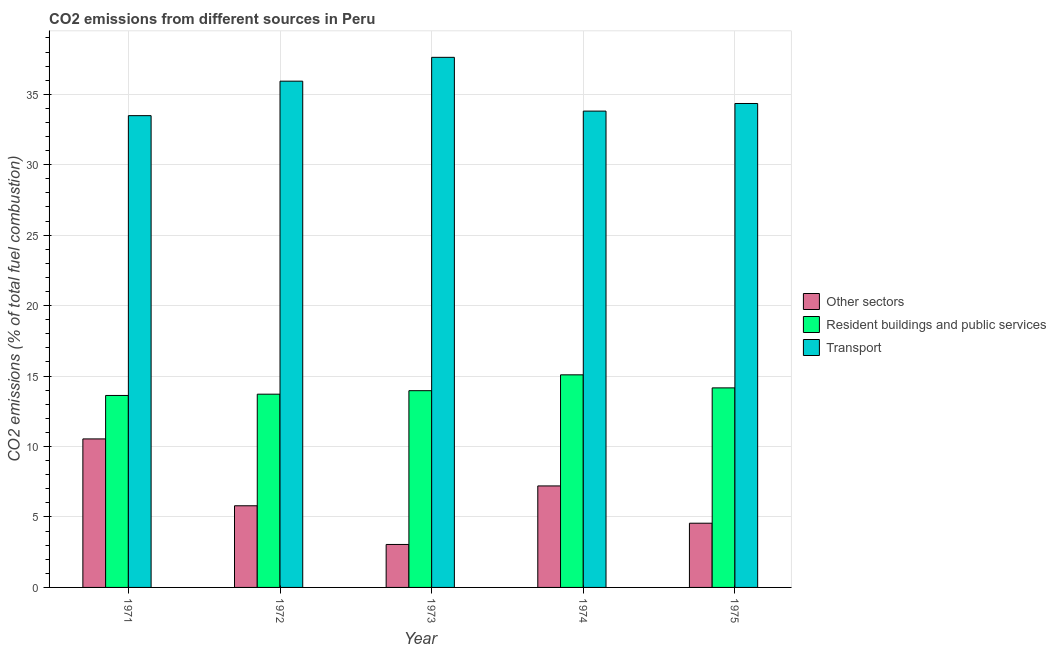How many different coloured bars are there?
Ensure brevity in your answer.  3. How many groups of bars are there?
Give a very brief answer. 5. Are the number of bars on each tick of the X-axis equal?
Your answer should be very brief. Yes. What is the label of the 3rd group of bars from the left?
Ensure brevity in your answer.  1973. What is the percentage of co2 emissions from transport in 1975?
Make the answer very short. 34.35. Across all years, what is the maximum percentage of co2 emissions from transport?
Provide a succinct answer. 37.62. Across all years, what is the minimum percentage of co2 emissions from resident buildings and public services?
Your response must be concise. 13.62. In which year was the percentage of co2 emissions from resident buildings and public services maximum?
Provide a succinct answer. 1974. In which year was the percentage of co2 emissions from resident buildings and public services minimum?
Keep it short and to the point. 1971. What is the total percentage of co2 emissions from resident buildings and public services in the graph?
Offer a very short reply. 70.55. What is the difference between the percentage of co2 emissions from other sectors in 1971 and that in 1973?
Give a very brief answer. 7.49. What is the difference between the percentage of co2 emissions from other sectors in 1972 and the percentage of co2 emissions from resident buildings and public services in 1974?
Make the answer very short. -1.41. What is the average percentage of co2 emissions from transport per year?
Keep it short and to the point. 35.04. In the year 1972, what is the difference between the percentage of co2 emissions from transport and percentage of co2 emissions from resident buildings and public services?
Your answer should be very brief. 0. In how many years, is the percentage of co2 emissions from other sectors greater than 18 %?
Give a very brief answer. 0. What is the ratio of the percentage of co2 emissions from resident buildings and public services in 1972 to that in 1974?
Provide a succinct answer. 0.91. Is the difference between the percentage of co2 emissions from resident buildings and public services in 1974 and 1975 greater than the difference between the percentage of co2 emissions from other sectors in 1974 and 1975?
Provide a short and direct response. No. What is the difference between the highest and the second highest percentage of co2 emissions from other sectors?
Your answer should be compact. 3.34. What is the difference between the highest and the lowest percentage of co2 emissions from other sectors?
Your answer should be very brief. 7.49. In how many years, is the percentage of co2 emissions from other sectors greater than the average percentage of co2 emissions from other sectors taken over all years?
Make the answer very short. 2. What does the 3rd bar from the left in 1971 represents?
Provide a succinct answer. Transport. What does the 2nd bar from the right in 1971 represents?
Offer a terse response. Resident buildings and public services. How many bars are there?
Give a very brief answer. 15. How many years are there in the graph?
Offer a terse response. 5. What is the difference between two consecutive major ticks on the Y-axis?
Your answer should be very brief. 5. Where does the legend appear in the graph?
Ensure brevity in your answer.  Center right. What is the title of the graph?
Your answer should be very brief. CO2 emissions from different sources in Peru. Does "New Zealand" appear as one of the legend labels in the graph?
Your answer should be very brief. No. What is the label or title of the Y-axis?
Offer a terse response. CO2 emissions (% of total fuel combustion). What is the CO2 emissions (% of total fuel combustion) in Other sectors in 1971?
Provide a succinct answer. 10.54. What is the CO2 emissions (% of total fuel combustion) in Resident buildings and public services in 1971?
Provide a succinct answer. 13.62. What is the CO2 emissions (% of total fuel combustion) of Transport in 1971?
Ensure brevity in your answer.  33.48. What is the CO2 emissions (% of total fuel combustion) in Other sectors in 1972?
Your response must be concise. 5.8. What is the CO2 emissions (% of total fuel combustion) in Resident buildings and public services in 1972?
Provide a short and direct response. 13.72. What is the CO2 emissions (% of total fuel combustion) of Transport in 1972?
Offer a very short reply. 35.93. What is the CO2 emissions (% of total fuel combustion) in Other sectors in 1973?
Keep it short and to the point. 3.05. What is the CO2 emissions (% of total fuel combustion) of Resident buildings and public services in 1973?
Offer a very short reply. 13.96. What is the CO2 emissions (% of total fuel combustion) of Transport in 1973?
Make the answer very short. 37.62. What is the CO2 emissions (% of total fuel combustion) of Other sectors in 1974?
Your answer should be compact. 7.2. What is the CO2 emissions (% of total fuel combustion) in Resident buildings and public services in 1974?
Keep it short and to the point. 15.09. What is the CO2 emissions (% of total fuel combustion) in Transport in 1974?
Provide a succinct answer. 33.81. What is the CO2 emissions (% of total fuel combustion) of Other sectors in 1975?
Provide a short and direct response. 4.56. What is the CO2 emissions (% of total fuel combustion) in Resident buildings and public services in 1975?
Provide a short and direct response. 14.16. What is the CO2 emissions (% of total fuel combustion) in Transport in 1975?
Offer a terse response. 34.35. Across all years, what is the maximum CO2 emissions (% of total fuel combustion) of Other sectors?
Keep it short and to the point. 10.54. Across all years, what is the maximum CO2 emissions (% of total fuel combustion) of Resident buildings and public services?
Your answer should be compact. 15.09. Across all years, what is the maximum CO2 emissions (% of total fuel combustion) of Transport?
Offer a terse response. 37.62. Across all years, what is the minimum CO2 emissions (% of total fuel combustion) in Other sectors?
Provide a succinct answer. 3.05. Across all years, what is the minimum CO2 emissions (% of total fuel combustion) in Resident buildings and public services?
Keep it short and to the point. 13.62. Across all years, what is the minimum CO2 emissions (% of total fuel combustion) in Transport?
Your answer should be compact. 33.48. What is the total CO2 emissions (% of total fuel combustion) of Other sectors in the graph?
Offer a terse response. 31.15. What is the total CO2 emissions (% of total fuel combustion) in Resident buildings and public services in the graph?
Your answer should be very brief. 70.55. What is the total CO2 emissions (% of total fuel combustion) in Transport in the graph?
Give a very brief answer. 175.19. What is the difference between the CO2 emissions (% of total fuel combustion) in Other sectors in 1971 and that in 1972?
Give a very brief answer. 4.74. What is the difference between the CO2 emissions (% of total fuel combustion) of Resident buildings and public services in 1971 and that in 1972?
Provide a short and direct response. -0.09. What is the difference between the CO2 emissions (% of total fuel combustion) in Transport in 1971 and that in 1972?
Give a very brief answer. -2.45. What is the difference between the CO2 emissions (% of total fuel combustion) in Other sectors in 1971 and that in 1973?
Provide a short and direct response. 7.49. What is the difference between the CO2 emissions (% of total fuel combustion) of Resident buildings and public services in 1971 and that in 1973?
Your response must be concise. -0.34. What is the difference between the CO2 emissions (% of total fuel combustion) in Transport in 1971 and that in 1973?
Offer a terse response. -4.14. What is the difference between the CO2 emissions (% of total fuel combustion) in Other sectors in 1971 and that in 1974?
Offer a terse response. 3.34. What is the difference between the CO2 emissions (% of total fuel combustion) of Resident buildings and public services in 1971 and that in 1974?
Make the answer very short. -1.46. What is the difference between the CO2 emissions (% of total fuel combustion) in Transport in 1971 and that in 1974?
Your answer should be very brief. -0.32. What is the difference between the CO2 emissions (% of total fuel combustion) in Other sectors in 1971 and that in 1975?
Keep it short and to the point. 5.98. What is the difference between the CO2 emissions (% of total fuel combustion) in Resident buildings and public services in 1971 and that in 1975?
Provide a succinct answer. -0.54. What is the difference between the CO2 emissions (% of total fuel combustion) of Transport in 1971 and that in 1975?
Offer a very short reply. -0.86. What is the difference between the CO2 emissions (% of total fuel combustion) in Other sectors in 1972 and that in 1973?
Give a very brief answer. 2.75. What is the difference between the CO2 emissions (% of total fuel combustion) of Resident buildings and public services in 1972 and that in 1973?
Make the answer very short. -0.25. What is the difference between the CO2 emissions (% of total fuel combustion) in Transport in 1972 and that in 1973?
Provide a short and direct response. -1.69. What is the difference between the CO2 emissions (% of total fuel combustion) in Other sectors in 1972 and that in 1974?
Offer a terse response. -1.41. What is the difference between the CO2 emissions (% of total fuel combustion) of Resident buildings and public services in 1972 and that in 1974?
Make the answer very short. -1.37. What is the difference between the CO2 emissions (% of total fuel combustion) of Transport in 1972 and that in 1974?
Ensure brevity in your answer.  2.12. What is the difference between the CO2 emissions (% of total fuel combustion) in Other sectors in 1972 and that in 1975?
Offer a terse response. 1.24. What is the difference between the CO2 emissions (% of total fuel combustion) of Resident buildings and public services in 1972 and that in 1975?
Keep it short and to the point. -0.45. What is the difference between the CO2 emissions (% of total fuel combustion) in Transport in 1972 and that in 1975?
Make the answer very short. 1.58. What is the difference between the CO2 emissions (% of total fuel combustion) of Other sectors in 1973 and that in 1974?
Make the answer very short. -4.15. What is the difference between the CO2 emissions (% of total fuel combustion) in Resident buildings and public services in 1973 and that in 1974?
Provide a short and direct response. -1.12. What is the difference between the CO2 emissions (% of total fuel combustion) in Transport in 1973 and that in 1974?
Offer a terse response. 3.82. What is the difference between the CO2 emissions (% of total fuel combustion) in Other sectors in 1973 and that in 1975?
Provide a short and direct response. -1.51. What is the difference between the CO2 emissions (% of total fuel combustion) of Resident buildings and public services in 1973 and that in 1975?
Keep it short and to the point. -0.2. What is the difference between the CO2 emissions (% of total fuel combustion) in Transport in 1973 and that in 1975?
Your response must be concise. 3.28. What is the difference between the CO2 emissions (% of total fuel combustion) in Other sectors in 1974 and that in 1975?
Your answer should be compact. 2.65. What is the difference between the CO2 emissions (% of total fuel combustion) of Resident buildings and public services in 1974 and that in 1975?
Ensure brevity in your answer.  0.93. What is the difference between the CO2 emissions (% of total fuel combustion) in Transport in 1974 and that in 1975?
Make the answer very short. -0.54. What is the difference between the CO2 emissions (% of total fuel combustion) of Other sectors in 1971 and the CO2 emissions (% of total fuel combustion) of Resident buildings and public services in 1972?
Offer a very short reply. -3.18. What is the difference between the CO2 emissions (% of total fuel combustion) of Other sectors in 1971 and the CO2 emissions (% of total fuel combustion) of Transport in 1972?
Your answer should be compact. -25.39. What is the difference between the CO2 emissions (% of total fuel combustion) of Resident buildings and public services in 1971 and the CO2 emissions (% of total fuel combustion) of Transport in 1972?
Provide a succinct answer. -22.31. What is the difference between the CO2 emissions (% of total fuel combustion) in Other sectors in 1971 and the CO2 emissions (% of total fuel combustion) in Resident buildings and public services in 1973?
Keep it short and to the point. -3.42. What is the difference between the CO2 emissions (% of total fuel combustion) in Other sectors in 1971 and the CO2 emissions (% of total fuel combustion) in Transport in 1973?
Make the answer very short. -27.08. What is the difference between the CO2 emissions (% of total fuel combustion) of Resident buildings and public services in 1971 and the CO2 emissions (% of total fuel combustion) of Transport in 1973?
Your response must be concise. -24. What is the difference between the CO2 emissions (% of total fuel combustion) of Other sectors in 1971 and the CO2 emissions (% of total fuel combustion) of Resident buildings and public services in 1974?
Your response must be concise. -4.55. What is the difference between the CO2 emissions (% of total fuel combustion) of Other sectors in 1971 and the CO2 emissions (% of total fuel combustion) of Transport in 1974?
Provide a succinct answer. -23.27. What is the difference between the CO2 emissions (% of total fuel combustion) of Resident buildings and public services in 1971 and the CO2 emissions (% of total fuel combustion) of Transport in 1974?
Offer a very short reply. -20.18. What is the difference between the CO2 emissions (% of total fuel combustion) in Other sectors in 1971 and the CO2 emissions (% of total fuel combustion) in Resident buildings and public services in 1975?
Your response must be concise. -3.62. What is the difference between the CO2 emissions (% of total fuel combustion) in Other sectors in 1971 and the CO2 emissions (% of total fuel combustion) in Transport in 1975?
Ensure brevity in your answer.  -23.81. What is the difference between the CO2 emissions (% of total fuel combustion) in Resident buildings and public services in 1971 and the CO2 emissions (% of total fuel combustion) in Transport in 1975?
Your answer should be compact. -20.72. What is the difference between the CO2 emissions (% of total fuel combustion) of Other sectors in 1972 and the CO2 emissions (% of total fuel combustion) of Resident buildings and public services in 1973?
Your response must be concise. -8.17. What is the difference between the CO2 emissions (% of total fuel combustion) of Other sectors in 1972 and the CO2 emissions (% of total fuel combustion) of Transport in 1973?
Your response must be concise. -31.83. What is the difference between the CO2 emissions (% of total fuel combustion) in Resident buildings and public services in 1972 and the CO2 emissions (% of total fuel combustion) in Transport in 1973?
Offer a terse response. -23.91. What is the difference between the CO2 emissions (% of total fuel combustion) in Other sectors in 1972 and the CO2 emissions (% of total fuel combustion) in Resident buildings and public services in 1974?
Offer a terse response. -9.29. What is the difference between the CO2 emissions (% of total fuel combustion) in Other sectors in 1972 and the CO2 emissions (% of total fuel combustion) in Transport in 1974?
Provide a short and direct response. -28.01. What is the difference between the CO2 emissions (% of total fuel combustion) of Resident buildings and public services in 1972 and the CO2 emissions (% of total fuel combustion) of Transport in 1974?
Offer a terse response. -20.09. What is the difference between the CO2 emissions (% of total fuel combustion) in Other sectors in 1972 and the CO2 emissions (% of total fuel combustion) in Resident buildings and public services in 1975?
Make the answer very short. -8.37. What is the difference between the CO2 emissions (% of total fuel combustion) in Other sectors in 1972 and the CO2 emissions (% of total fuel combustion) in Transport in 1975?
Provide a short and direct response. -28.55. What is the difference between the CO2 emissions (% of total fuel combustion) in Resident buildings and public services in 1972 and the CO2 emissions (% of total fuel combustion) in Transport in 1975?
Your answer should be very brief. -20.63. What is the difference between the CO2 emissions (% of total fuel combustion) in Other sectors in 1973 and the CO2 emissions (% of total fuel combustion) in Resident buildings and public services in 1974?
Your answer should be compact. -12.04. What is the difference between the CO2 emissions (% of total fuel combustion) in Other sectors in 1973 and the CO2 emissions (% of total fuel combustion) in Transport in 1974?
Ensure brevity in your answer.  -30.76. What is the difference between the CO2 emissions (% of total fuel combustion) of Resident buildings and public services in 1973 and the CO2 emissions (% of total fuel combustion) of Transport in 1974?
Ensure brevity in your answer.  -19.84. What is the difference between the CO2 emissions (% of total fuel combustion) in Other sectors in 1973 and the CO2 emissions (% of total fuel combustion) in Resident buildings and public services in 1975?
Provide a short and direct response. -11.11. What is the difference between the CO2 emissions (% of total fuel combustion) in Other sectors in 1973 and the CO2 emissions (% of total fuel combustion) in Transport in 1975?
Provide a succinct answer. -31.3. What is the difference between the CO2 emissions (% of total fuel combustion) of Resident buildings and public services in 1973 and the CO2 emissions (% of total fuel combustion) of Transport in 1975?
Ensure brevity in your answer.  -20.38. What is the difference between the CO2 emissions (% of total fuel combustion) in Other sectors in 1974 and the CO2 emissions (% of total fuel combustion) in Resident buildings and public services in 1975?
Offer a terse response. -6.96. What is the difference between the CO2 emissions (% of total fuel combustion) in Other sectors in 1974 and the CO2 emissions (% of total fuel combustion) in Transport in 1975?
Make the answer very short. -27.14. What is the difference between the CO2 emissions (% of total fuel combustion) of Resident buildings and public services in 1974 and the CO2 emissions (% of total fuel combustion) of Transport in 1975?
Provide a short and direct response. -19.26. What is the average CO2 emissions (% of total fuel combustion) in Other sectors per year?
Keep it short and to the point. 6.23. What is the average CO2 emissions (% of total fuel combustion) of Resident buildings and public services per year?
Make the answer very short. 14.11. What is the average CO2 emissions (% of total fuel combustion) in Transport per year?
Your response must be concise. 35.04. In the year 1971, what is the difference between the CO2 emissions (% of total fuel combustion) in Other sectors and CO2 emissions (% of total fuel combustion) in Resident buildings and public services?
Your response must be concise. -3.08. In the year 1971, what is the difference between the CO2 emissions (% of total fuel combustion) of Other sectors and CO2 emissions (% of total fuel combustion) of Transport?
Your answer should be compact. -22.94. In the year 1971, what is the difference between the CO2 emissions (% of total fuel combustion) in Resident buildings and public services and CO2 emissions (% of total fuel combustion) in Transport?
Keep it short and to the point. -19.86. In the year 1972, what is the difference between the CO2 emissions (% of total fuel combustion) of Other sectors and CO2 emissions (% of total fuel combustion) of Resident buildings and public services?
Provide a succinct answer. -7.92. In the year 1972, what is the difference between the CO2 emissions (% of total fuel combustion) of Other sectors and CO2 emissions (% of total fuel combustion) of Transport?
Offer a very short reply. -30.14. In the year 1972, what is the difference between the CO2 emissions (% of total fuel combustion) in Resident buildings and public services and CO2 emissions (% of total fuel combustion) in Transport?
Offer a very short reply. -22.22. In the year 1973, what is the difference between the CO2 emissions (% of total fuel combustion) of Other sectors and CO2 emissions (% of total fuel combustion) of Resident buildings and public services?
Ensure brevity in your answer.  -10.91. In the year 1973, what is the difference between the CO2 emissions (% of total fuel combustion) in Other sectors and CO2 emissions (% of total fuel combustion) in Transport?
Your answer should be very brief. -34.57. In the year 1973, what is the difference between the CO2 emissions (% of total fuel combustion) of Resident buildings and public services and CO2 emissions (% of total fuel combustion) of Transport?
Give a very brief answer. -23.66. In the year 1974, what is the difference between the CO2 emissions (% of total fuel combustion) of Other sectors and CO2 emissions (% of total fuel combustion) of Resident buildings and public services?
Make the answer very short. -7.88. In the year 1974, what is the difference between the CO2 emissions (% of total fuel combustion) of Other sectors and CO2 emissions (% of total fuel combustion) of Transport?
Offer a terse response. -26.6. In the year 1974, what is the difference between the CO2 emissions (% of total fuel combustion) in Resident buildings and public services and CO2 emissions (% of total fuel combustion) in Transport?
Ensure brevity in your answer.  -18.72. In the year 1975, what is the difference between the CO2 emissions (% of total fuel combustion) in Other sectors and CO2 emissions (% of total fuel combustion) in Resident buildings and public services?
Give a very brief answer. -9.6. In the year 1975, what is the difference between the CO2 emissions (% of total fuel combustion) in Other sectors and CO2 emissions (% of total fuel combustion) in Transport?
Offer a terse response. -29.79. In the year 1975, what is the difference between the CO2 emissions (% of total fuel combustion) in Resident buildings and public services and CO2 emissions (% of total fuel combustion) in Transport?
Your answer should be compact. -20.18. What is the ratio of the CO2 emissions (% of total fuel combustion) in Other sectors in 1971 to that in 1972?
Provide a succinct answer. 1.82. What is the ratio of the CO2 emissions (% of total fuel combustion) of Transport in 1971 to that in 1972?
Your answer should be very brief. 0.93. What is the ratio of the CO2 emissions (% of total fuel combustion) in Other sectors in 1971 to that in 1973?
Offer a terse response. 3.46. What is the ratio of the CO2 emissions (% of total fuel combustion) in Resident buildings and public services in 1971 to that in 1973?
Provide a short and direct response. 0.98. What is the ratio of the CO2 emissions (% of total fuel combustion) in Transport in 1971 to that in 1973?
Your answer should be compact. 0.89. What is the ratio of the CO2 emissions (% of total fuel combustion) of Other sectors in 1971 to that in 1974?
Keep it short and to the point. 1.46. What is the ratio of the CO2 emissions (% of total fuel combustion) in Resident buildings and public services in 1971 to that in 1974?
Make the answer very short. 0.9. What is the ratio of the CO2 emissions (% of total fuel combustion) in Other sectors in 1971 to that in 1975?
Offer a very short reply. 2.31. What is the ratio of the CO2 emissions (% of total fuel combustion) of Resident buildings and public services in 1971 to that in 1975?
Provide a succinct answer. 0.96. What is the ratio of the CO2 emissions (% of total fuel combustion) of Transport in 1971 to that in 1975?
Offer a terse response. 0.97. What is the ratio of the CO2 emissions (% of total fuel combustion) in Other sectors in 1972 to that in 1973?
Offer a very short reply. 1.9. What is the ratio of the CO2 emissions (% of total fuel combustion) of Resident buildings and public services in 1972 to that in 1973?
Make the answer very short. 0.98. What is the ratio of the CO2 emissions (% of total fuel combustion) of Transport in 1972 to that in 1973?
Provide a succinct answer. 0.95. What is the ratio of the CO2 emissions (% of total fuel combustion) in Other sectors in 1972 to that in 1974?
Your response must be concise. 0.8. What is the ratio of the CO2 emissions (% of total fuel combustion) in Resident buildings and public services in 1972 to that in 1974?
Keep it short and to the point. 0.91. What is the ratio of the CO2 emissions (% of total fuel combustion) in Transport in 1972 to that in 1974?
Give a very brief answer. 1.06. What is the ratio of the CO2 emissions (% of total fuel combustion) of Other sectors in 1972 to that in 1975?
Your answer should be compact. 1.27. What is the ratio of the CO2 emissions (% of total fuel combustion) in Resident buildings and public services in 1972 to that in 1975?
Your answer should be very brief. 0.97. What is the ratio of the CO2 emissions (% of total fuel combustion) in Transport in 1972 to that in 1975?
Provide a short and direct response. 1.05. What is the ratio of the CO2 emissions (% of total fuel combustion) of Other sectors in 1973 to that in 1974?
Ensure brevity in your answer.  0.42. What is the ratio of the CO2 emissions (% of total fuel combustion) in Resident buildings and public services in 1973 to that in 1974?
Provide a succinct answer. 0.93. What is the ratio of the CO2 emissions (% of total fuel combustion) of Transport in 1973 to that in 1974?
Ensure brevity in your answer.  1.11. What is the ratio of the CO2 emissions (% of total fuel combustion) in Other sectors in 1973 to that in 1975?
Offer a very short reply. 0.67. What is the ratio of the CO2 emissions (% of total fuel combustion) of Resident buildings and public services in 1973 to that in 1975?
Offer a very short reply. 0.99. What is the ratio of the CO2 emissions (% of total fuel combustion) of Transport in 1973 to that in 1975?
Your answer should be very brief. 1.1. What is the ratio of the CO2 emissions (% of total fuel combustion) in Other sectors in 1974 to that in 1975?
Provide a short and direct response. 1.58. What is the ratio of the CO2 emissions (% of total fuel combustion) in Resident buildings and public services in 1974 to that in 1975?
Give a very brief answer. 1.07. What is the ratio of the CO2 emissions (% of total fuel combustion) in Transport in 1974 to that in 1975?
Offer a terse response. 0.98. What is the difference between the highest and the second highest CO2 emissions (% of total fuel combustion) of Other sectors?
Your answer should be compact. 3.34. What is the difference between the highest and the second highest CO2 emissions (% of total fuel combustion) of Resident buildings and public services?
Your answer should be very brief. 0.93. What is the difference between the highest and the second highest CO2 emissions (% of total fuel combustion) in Transport?
Ensure brevity in your answer.  1.69. What is the difference between the highest and the lowest CO2 emissions (% of total fuel combustion) of Other sectors?
Keep it short and to the point. 7.49. What is the difference between the highest and the lowest CO2 emissions (% of total fuel combustion) of Resident buildings and public services?
Give a very brief answer. 1.46. What is the difference between the highest and the lowest CO2 emissions (% of total fuel combustion) of Transport?
Your answer should be very brief. 4.14. 